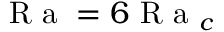<formula> <loc_0><loc_0><loc_500><loc_500>R a = 6 R a _ { c }</formula> 